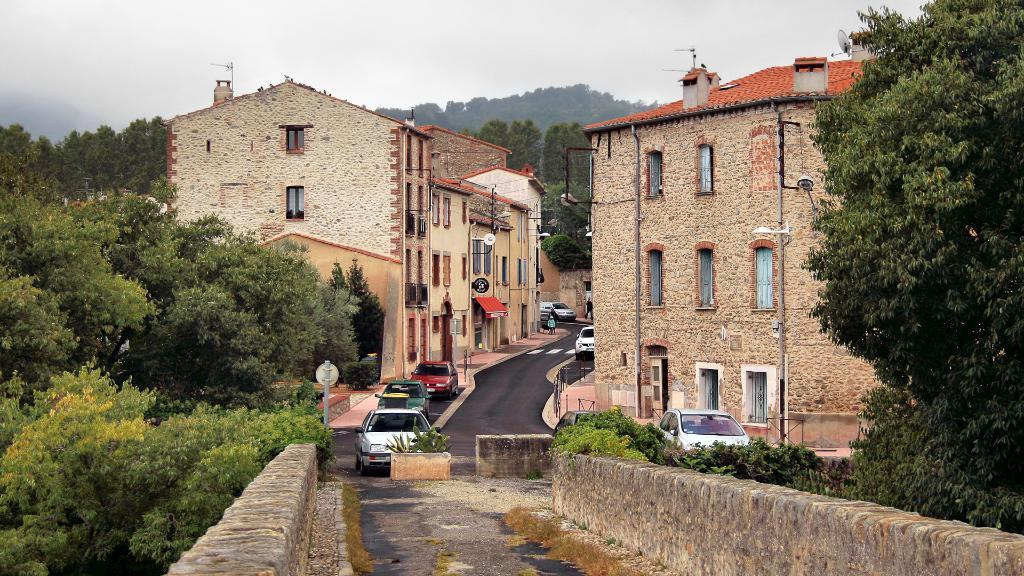What type of structures can be seen in the image? There are buildings in the image. What mode of transportation can be seen on the road in the image? There are cars on the road in the image. What type of vegetation is present in the image? There are trees in the image. What geographical features can be seen in the background of the image? There are hills visible in the background of the image. What is visible in the sky in the image? The sky is visible in the background of the image, and clouds are present. Can you see a snake slithering across the road in the image? There is no snake present in the image; it features buildings, cars, trees, hills, and a sky with clouds. 